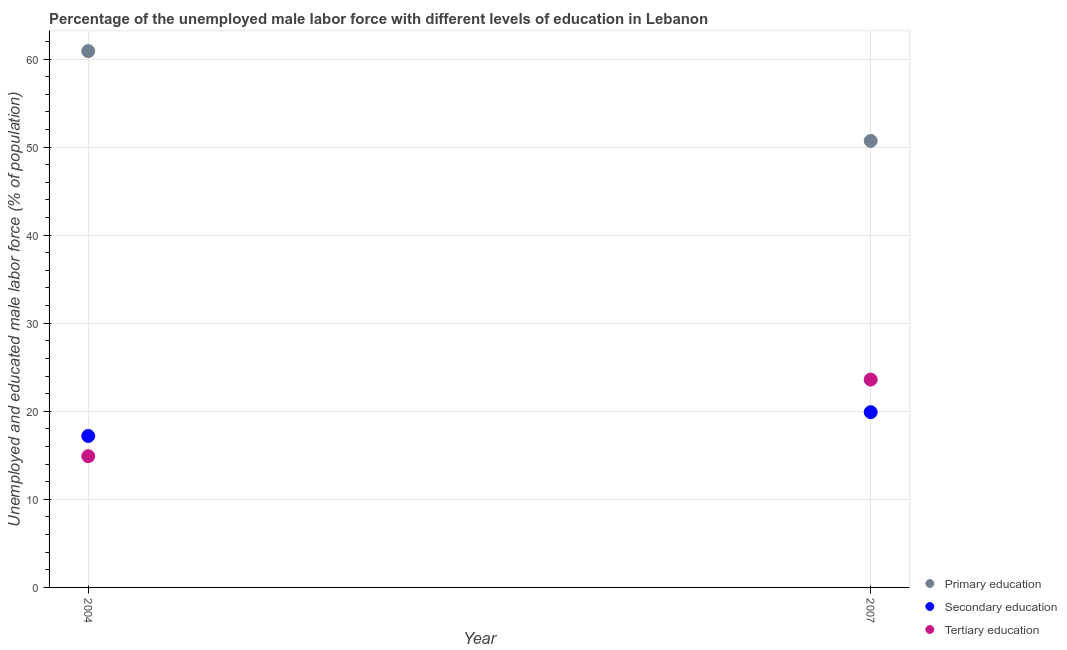What is the percentage of male labor force who received secondary education in 2004?
Your answer should be compact. 17.2. Across all years, what is the maximum percentage of male labor force who received primary education?
Provide a short and direct response. 60.9. Across all years, what is the minimum percentage of male labor force who received tertiary education?
Your answer should be very brief. 14.9. In which year was the percentage of male labor force who received tertiary education maximum?
Your response must be concise. 2007. In which year was the percentage of male labor force who received tertiary education minimum?
Make the answer very short. 2004. What is the total percentage of male labor force who received tertiary education in the graph?
Provide a short and direct response. 38.5. What is the difference between the percentage of male labor force who received primary education in 2004 and that in 2007?
Ensure brevity in your answer.  10.2. What is the difference between the percentage of male labor force who received primary education in 2007 and the percentage of male labor force who received secondary education in 2004?
Your response must be concise. 33.5. What is the average percentage of male labor force who received tertiary education per year?
Offer a very short reply. 19.25. In the year 2004, what is the difference between the percentage of male labor force who received secondary education and percentage of male labor force who received primary education?
Provide a short and direct response. -43.7. What is the ratio of the percentage of male labor force who received primary education in 2004 to that in 2007?
Your answer should be compact. 1.2. Is the percentage of male labor force who received primary education in 2004 less than that in 2007?
Provide a succinct answer. No. Is it the case that in every year, the sum of the percentage of male labor force who received primary education and percentage of male labor force who received secondary education is greater than the percentage of male labor force who received tertiary education?
Your response must be concise. Yes. Is the percentage of male labor force who received tertiary education strictly greater than the percentage of male labor force who received secondary education over the years?
Offer a terse response. No. Is the percentage of male labor force who received primary education strictly less than the percentage of male labor force who received tertiary education over the years?
Ensure brevity in your answer.  No. How many dotlines are there?
Provide a succinct answer. 3. How many years are there in the graph?
Your answer should be compact. 2. Where does the legend appear in the graph?
Your answer should be compact. Bottom right. How many legend labels are there?
Offer a very short reply. 3. What is the title of the graph?
Your answer should be very brief. Percentage of the unemployed male labor force with different levels of education in Lebanon. Does "Injury" appear as one of the legend labels in the graph?
Provide a short and direct response. No. What is the label or title of the Y-axis?
Make the answer very short. Unemployed and educated male labor force (% of population). What is the Unemployed and educated male labor force (% of population) in Primary education in 2004?
Your answer should be very brief. 60.9. What is the Unemployed and educated male labor force (% of population) of Secondary education in 2004?
Make the answer very short. 17.2. What is the Unemployed and educated male labor force (% of population) in Tertiary education in 2004?
Ensure brevity in your answer.  14.9. What is the Unemployed and educated male labor force (% of population) in Primary education in 2007?
Ensure brevity in your answer.  50.7. What is the Unemployed and educated male labor force (% of population) in Secondary education in 2007?
Provide a succinct answer. 19.9. What is the Unemployed and educated male labor force (% of population) of Tertiary education in 2007?
Provide a succinct answer. 23.6. Across all years, what is the maximum Unemployed and educated male labor force (% of population) in Primary education?
Provide a succinct answer. 60.9. Across all years, what is the maximum Unemployed and educated male labor force (% of population) of Secondary education?
Offer a very short reply. 19.9. Across all years, what is the maximum Unemployed and educated male labor force (% of population) of Tertiary education?
Provide a short and direct response. 23.6. Across all years, what is the minimum Unemployed and educated male labor force (% of population) in Primary education?
Make the answer very short. 50.7. Across all years, what is the minimum Unemployed and educated male labor force (% of population) in Secondary education?
Your answer should be compact. 17.2. Across all years, what is the minimum Unemployed and educated male labor force (% of population) in Tertiary education?
Provide a short and direct response. 14.9. What is the total Unemployed and educated male labor force (% of population) of Primary education in the graph?
Your response must be concise. 111.6. What is the total Unemployed and educated male labor force (% of population) in Secondary education in the graph?
Offer a terse response. 37.1. What is the total Unemployed and educated male labor force (% of population) of Tertiary education in the graph?
Offer a very short reply. 38.5. What is the difference between the Unemployed and educated male labor force (% of population) of Primary education in 2004 and that in 2007?
Your answer should be very brief. 10.2. What is the difference between the Unemployed and educated male labor force (% of population) in Tertiary education in 2004 and that in 2007?
Provide a succinct answer. -8.7. What is the difference between the Unemployed and educated male labor force (% of population) of Primary education in 2004 and the Unemployed and educated male labor force (% of population) of Secondary education in 2007?
Ensure brevity in your answer.  41. What is the difference between the Unemployed and educated male labor force (% of population) of Primary education in 2004 and the Unemployed and educated male labor force (% of population) of Tertiary education in 2007?
Give a very brief answer. 37.3. What is the average Unemployed and educated male labor force (% of population) in Primary education per year?
Give a very brief answer. 55.8. What is the average Unemployed and educated male labor force (% of population) in Secondary education per year?
Give a very brief answer. 18.55. What is the average Unemployed and educated male labor force (% of population) in Tertiary education per year?
Your answer should be compact. 19.25. In the year 2004, what is the difference between the Unemployed and educated male labor force (% of population) of Primary education and Unemployed and educated male labor force (% of population) of Secondary education?
Your response must be concise. 43.7. In the year 2004, what is the difference between the Unemployed and educated male labor force (% of population) of Primary education and Unemployed and educated male labor force (% of population) of Tertiary education?
Keep it short and to the point. 46. In the year 2004, what is the difference between the Unemployed and educated male labor force (% of population) of Secondary education and Unemployed and educated male labor force (% of population) of Tertiary education?
Keep it short and to the point. 2.3. In the year 2007, what is the difference between the Unemployed and educated male labor force (% of population) in Primary education and Unemployed and educated male labor force (% of population) in Secondary education?
Make the answer very short. 30.8. In the year 2007, what is the difference between the Unemployed and educated male labor force (% of population) in Primary education and Unemployed and educated male labor force (% of population) in Tertiary education?
Provide a short and direct response. 27.1. What is the ratio of the Unemployed and educated male labor force (% of population) of Primary education in 2004 to that in 2007?
Your answer should be very brief. 1.2. What is the ratio of the Unemployed and educated male labor force (% of population) of Secondary education in 2004 to that in 2007?
Offer a very short reply. 0.86. What is the ratio of the Unemployed and educated male labor force (% of population) of Tertiary education in 2004 to that in 2007?
Your answer should be compact. 0.63. What is the difference between the highest and the second highest Unemployed and educated male labor force (% of population) of Primary education?
Make the answer very short. 10.2. What is the difference between the highest and the second highest Unemployed and educated male labor force (% of population) of Secondary education?
Your answer should be compact. 2.7. 